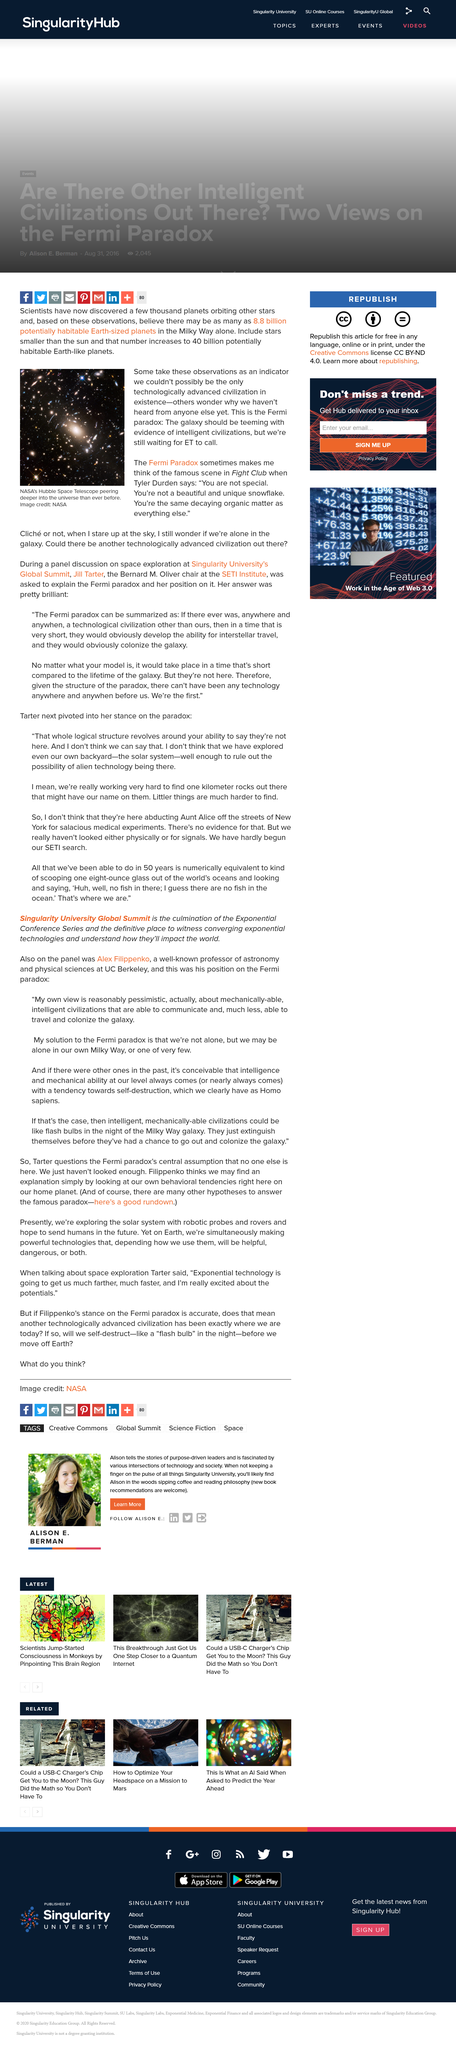Give some essential details in this illustration. There are 40 billion Earth-like planets in the universe, but not a single civilization has been contacted, leading to the definition of the Fermi Paradox. There are a staggering 8.8 billion potentially habitable Earth-sized planets in the Milky Way, according to recent estimates. The movie that features a character named Tyler Durden is Fight Club, and Tyler Durden is a character in that movie. 